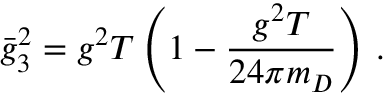Convert formula to latex. <formula><loc_0><loc_0><loc_500><loc_500>\bar { g } _ { 3 } ^ { 2 } = g ^ { 2 } T \left ( 1 - \frac { g ^ { 2 } T } { 2 4 \pi m _ { D } } \right ) \, .</formula> 